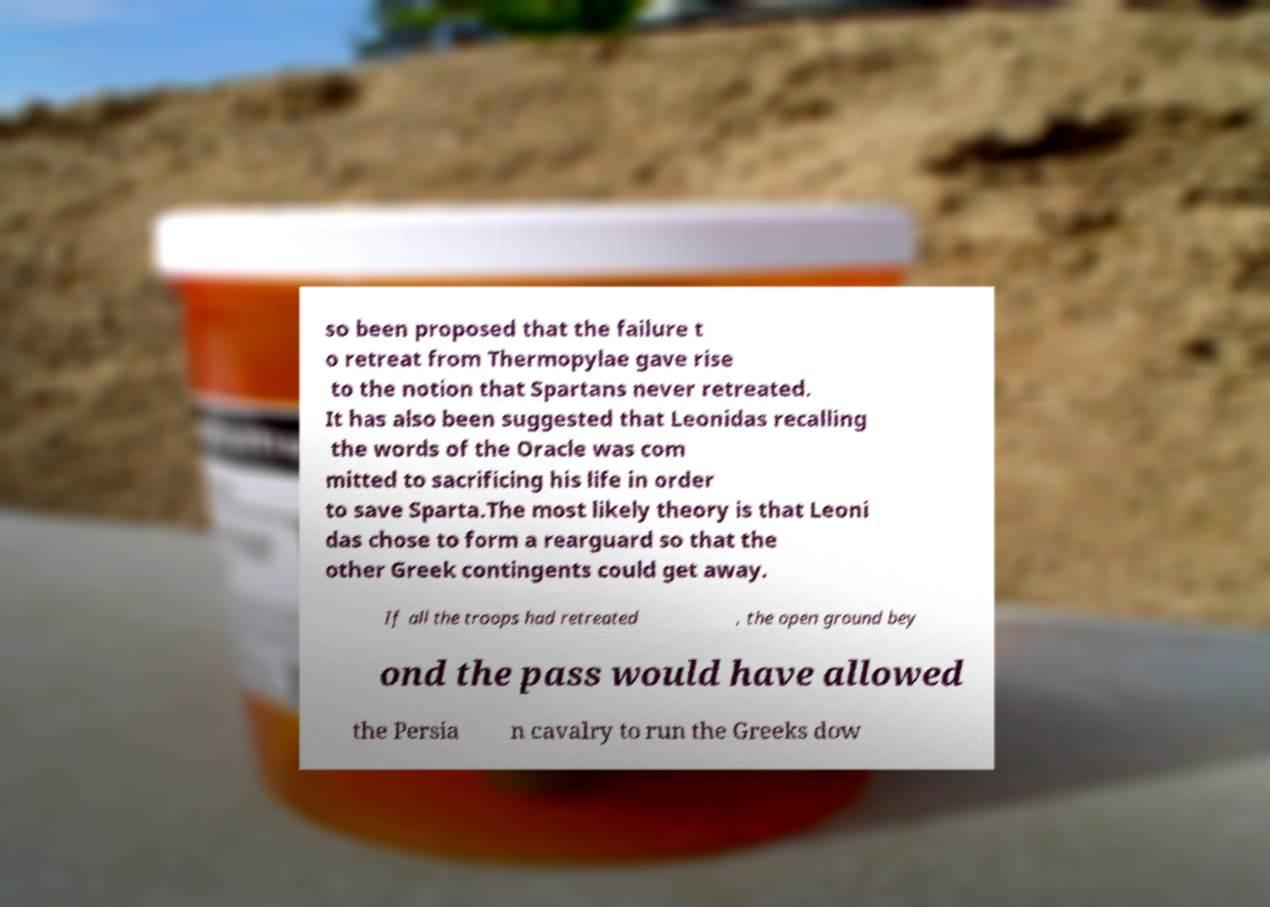For documentation purposes, I need the text within this image transcribed. Could you provide that? so been proposed that the failure t o retreat from Thermopylae gave rise to the notion that Spartans never retreated. It has also been suggested that Leonidas recalling the words of the Oracle was com mitted to sacrificing his life in order to save Sparta.The most likely theory is that Leoni das chose to form a rearguard so that the other Greek contingents could get away. If all the troops had retreated , the open ground bey ond the pass would have allowed the Persia n cavalry to run the Greeks dow 